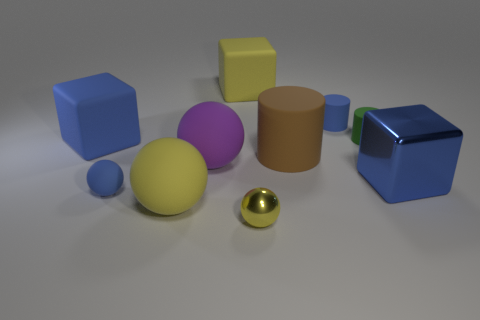There is a metal cube that is the same color as the small rubber sphere; what is its size?
Offer a very short reply. Large. The large metal cube has what color?
Provide a short and direct response. Blue. There is a brown matte cylinder behind the blue metallic object; how big is it?
Offer a very short reply. Large. What number of small blue rubber spheres are to the left of the block that is on the right side of the matte cylinder right of the small blue cylinder?
Give a very brief answer. 1. There is a matte cube that is in front of the small blue rubber thing behind the green rubber cylinder; what is its color?
Offer a terse response. Blue. Are there any cylinders that have the same size as the yellow block?
Provide a succinct answer. Yes. There is a big ball that is behind the blue cube that is on the right side of the yellow matte sphere to the left of the small green matte cylinder; what is its material?
Your response must be concise. Rubber. There is a big rubber block that is behind the tiny green cylinder; how many tiny blue cylinders are to the left of it?
Provide a short and direct response. 0. Does the rubber ball behind the blue sphere have the same size as the shiny ball?
Offer a terse response. No. What number of other things have the same shape as the big metallic object?
Make the answer very short. 2. 